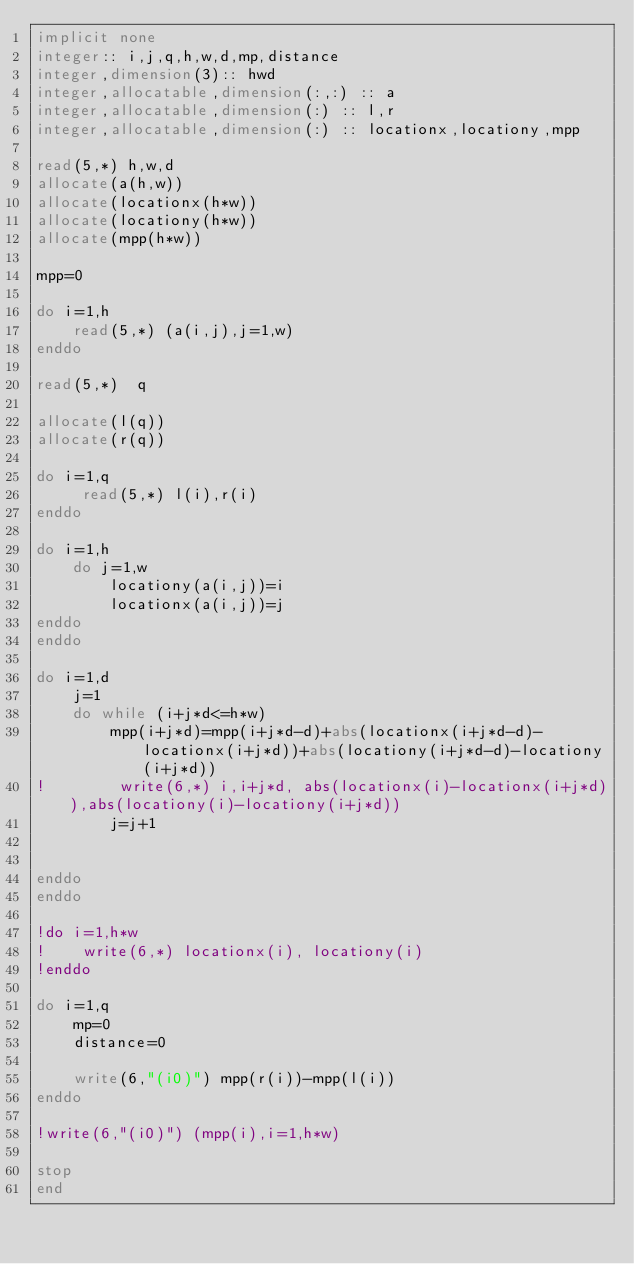<code> <loc_0><loc_0><loc_500><loc_500><_FORTRAN_>implicit none
integer:: i,j,q,h,w,d,mp,distance
integer,dimension(3):: hwd
integer,allocatable,dimension(:,:) :: a
integer,allocatable,dimension(:) :: l,r
integer,allocatable,dimension(:) :: locationx,locationy,mpp

read(5,*) h,w,d
allocate(a(h,w))
allocate(locationx(h*w))
allocate(locationy(h*w))
allocate(mpp(h*w))

mpp=0

do i=1,h
    read(5,*) (a(i,j),j=1,w)
enddo

read(5,*)  q

allocate(l(q))
allocate(r(q))

do i=1,q
     read(5,*) l(i),r(i)
enddo

do i=1,h
    do j=1,w
        locationy(a(i,j))=i
        locationx(a(i,j))=j
enddo
enddo

do i=1,d
    j=1
    do while (i+j*d<=h*w)    
        mpp(i+j*d)=mpp(i+j*d-d)+abs(locationx(i+j*d-d)-locationx(i+j*d))+abs(locationy(i+j*d-d)-locationy(i+j*d))
!        write(6,*) i,i+j*d, abs(locationx(i)-locationx(i+j*d)),abs(locationy(i)-locationy(i+j*d))
        j=j+1


enddo
enddo

!do i=1,h*w
!    write(6,*) locationx(i), locationy(i)
!enddo

do i=1,q
    mp=0
    distance=0

    write(6,"(i0)") mpp(r(i))-mpp(l(i))
enddo

!write(6,"(i0)") (mpp(i),i=1,h*w)

stop
end</code> 